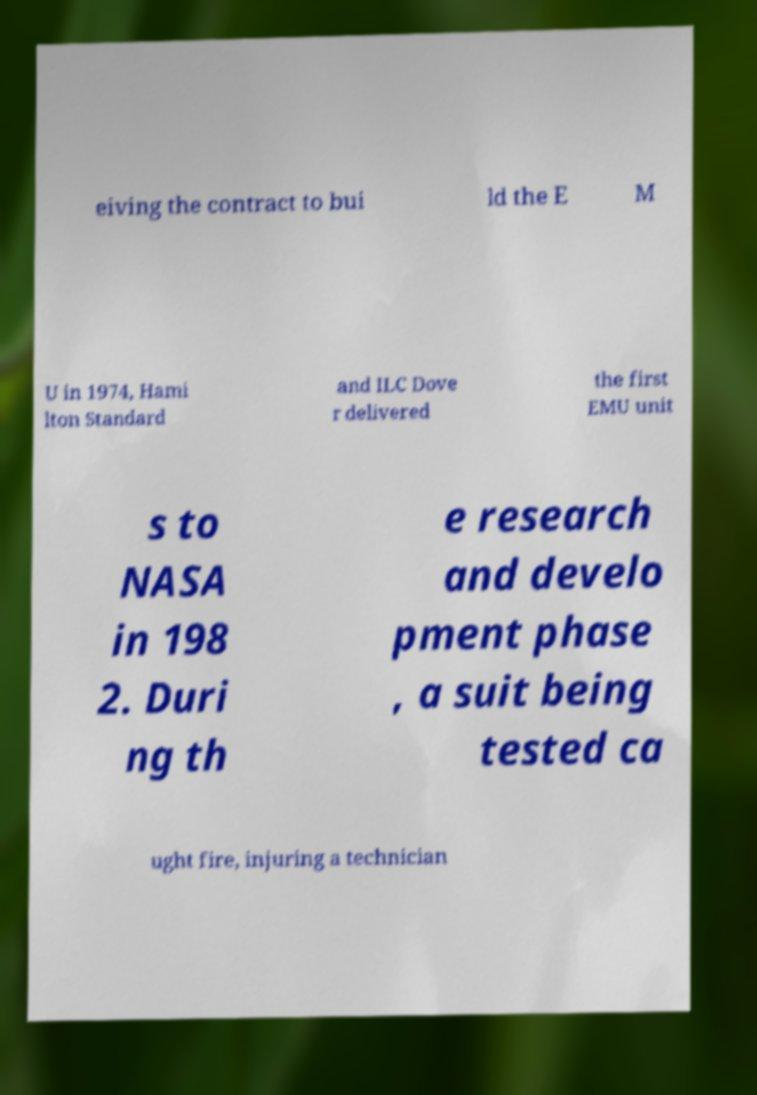Please identify and transcribe the text found in this image. eiving the contract to bui ld the E M U in 1974, Hami lton Standard and ILC Dove r delivered the first EMU unit s to NASA in 198 2. Duri ng th e research and develo pment phase , a suit being tested ca ught fire, injuring a technician 